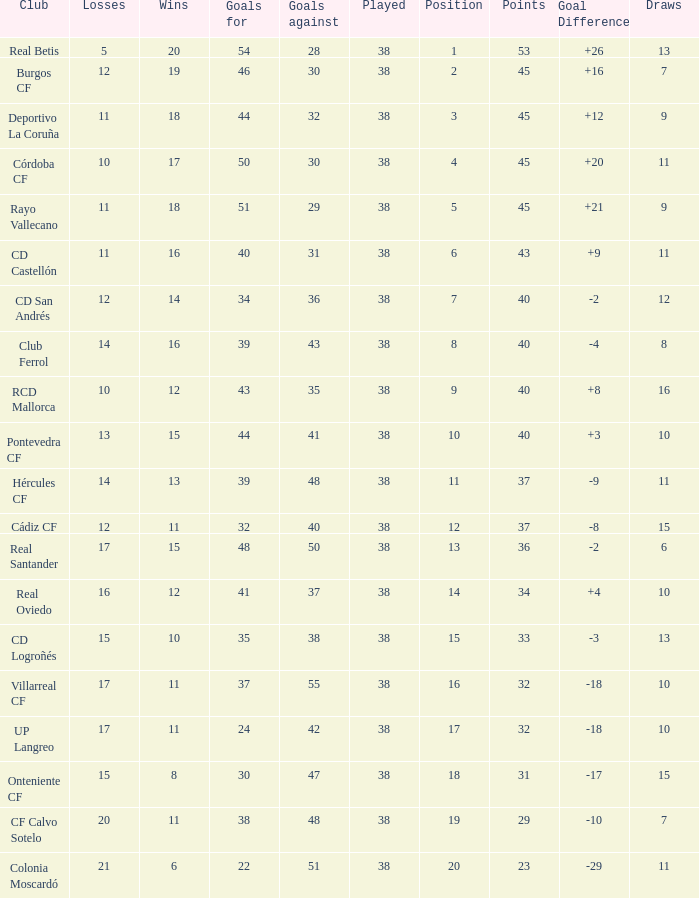What is the highest Goals Against, when Club is "Pontevedra CF", and when Played is less than 38? None. 